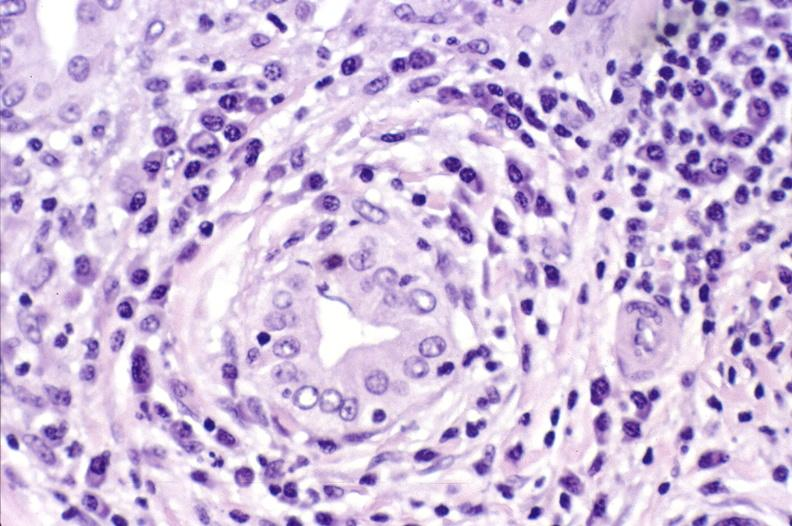s hepatobiliary present?
Answer the question using a single word or phrase. Yes 